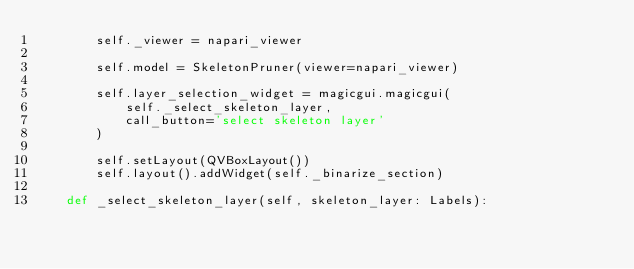Convert code to text. <code><loc_0><loc_0><loc_500><loc_500><_Python_>        self._viewer = napari_viewer

        self.model = SkeletonPruner(viewer=napari_viewer)

        self.layer_selection_widget = magicgui.magicgui(
            self._select_skeleton_layer,
            call_button='select skeleton layer'
        )

        self.setLayout(QVBoxLayout())
        self.layout().addWidget(self._binarize_section)

    def _select_skeleton_layer(self, skeleton_layer: Labels):</code> 